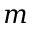<formula> <loc_0><loc_0><loc_500><loc_500>m</formula> 